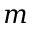<formula> <loc_0><loc_0><loc_500><loc_500>m</formula> 